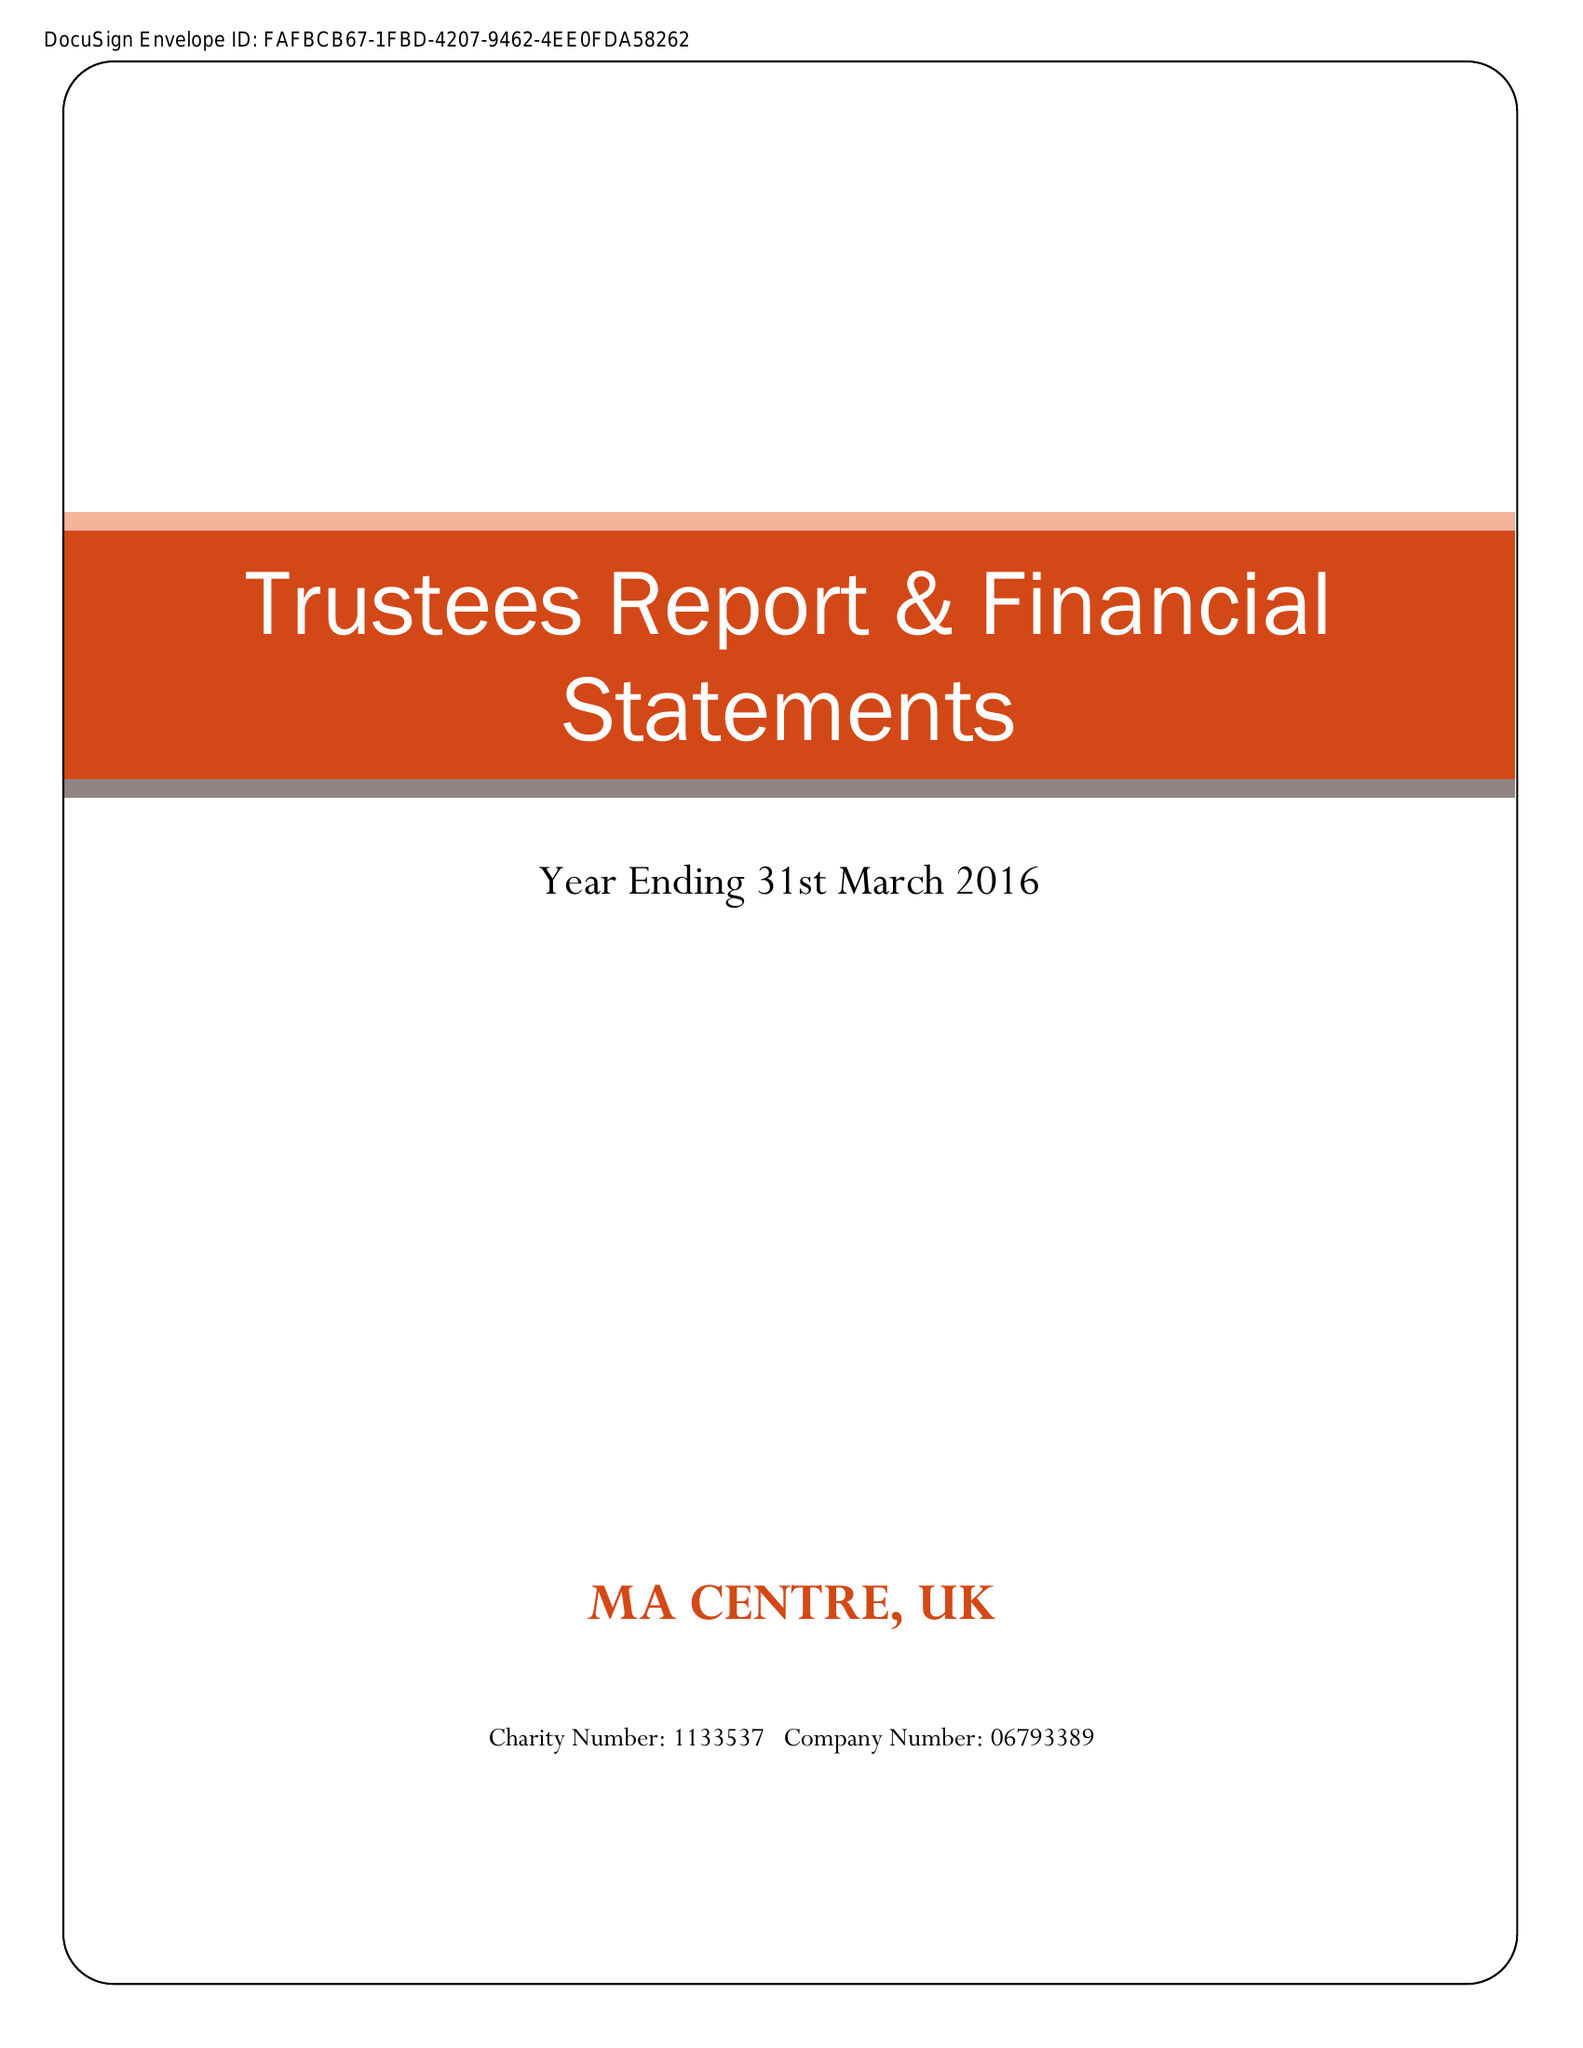What is the value for the charity_number?
Answer the question using a single word or phrase. 1133537 